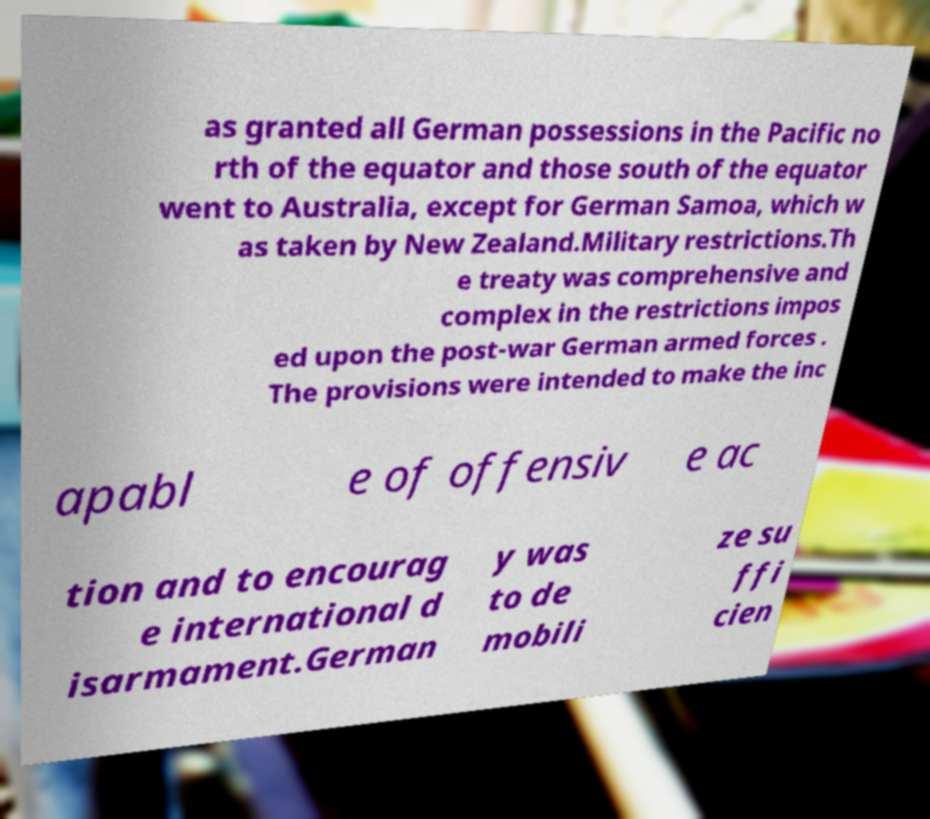Can you read and provide the text displayed in the image?This photo seems to have some interesting text. Can you extract and type it out for me? as granted all German possessions in the Pacific no rth of the equator and those south of the equator went to Australia, except for German Samoa, which w as taken by New Zealand.Military restrictions.Th e treaty was comprehensive and complex in the restrictions impos ed upon the post-war German armed forces . The provisions were intended to make the inc apabl e of offensiv e ac tion and to encourag e international d isarmament.German y was to de mobili ze su ffi cien 